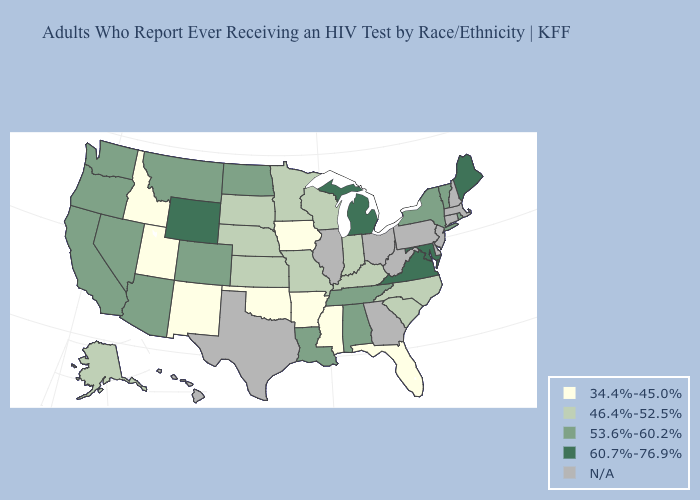What is the value of New Hampshire?
Answer briefly. N/A. Does Utah have the lowest value in the USA?
Concise answer only. Yes. Does Oregon have the highest value in the USA?
Concise answer only. No. What is the highest value in the USA?
Answer briefly. 60.7%-76.9%. What is the value of Louisiana?
Short answer required. 53.6%-60.2%. What is the highest value in states that border Wisconsin?
Short answer required. 60.7%-76.9%. What is the value of Louisiana?
Concise answer only. 53.6%-60.2%. What is the highest value in states that border Oregon?
Give a very brief answer. 53.6%-60.2%. What is the lowest value in the MidWest?
Answer briefly. 34.4%-45.0%. Name the states that have a value in the range 34.4%-45.0%?
Concise answer only. Arkansas, Florida, Idaho, Iowa, Mississippi, New Mexico, Oklahoma, Utah. Does Arizona have the highest value in the West?
Be succinct. No. Does Missouri have the highest value in the MidWest?
Quick response, please. No. 